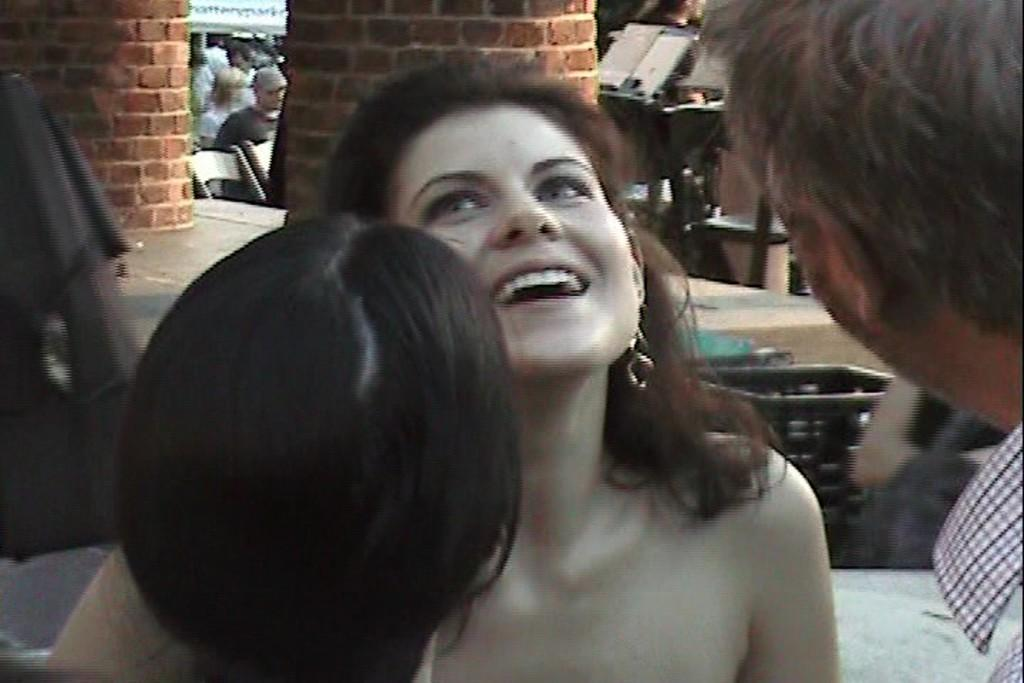Who is the main subject in the image? There is a girl in the image. What is the girl doing in the image? The girl is looking at someone and smiling. Can you describe the person on the right side of the image? Unfortunately, the facts provided do not give any information about the person on the right side of the image. What type of boats can be seen in the image? There are no boats present in the image. Where is the bed located in the image? There is no bed present in the image. 